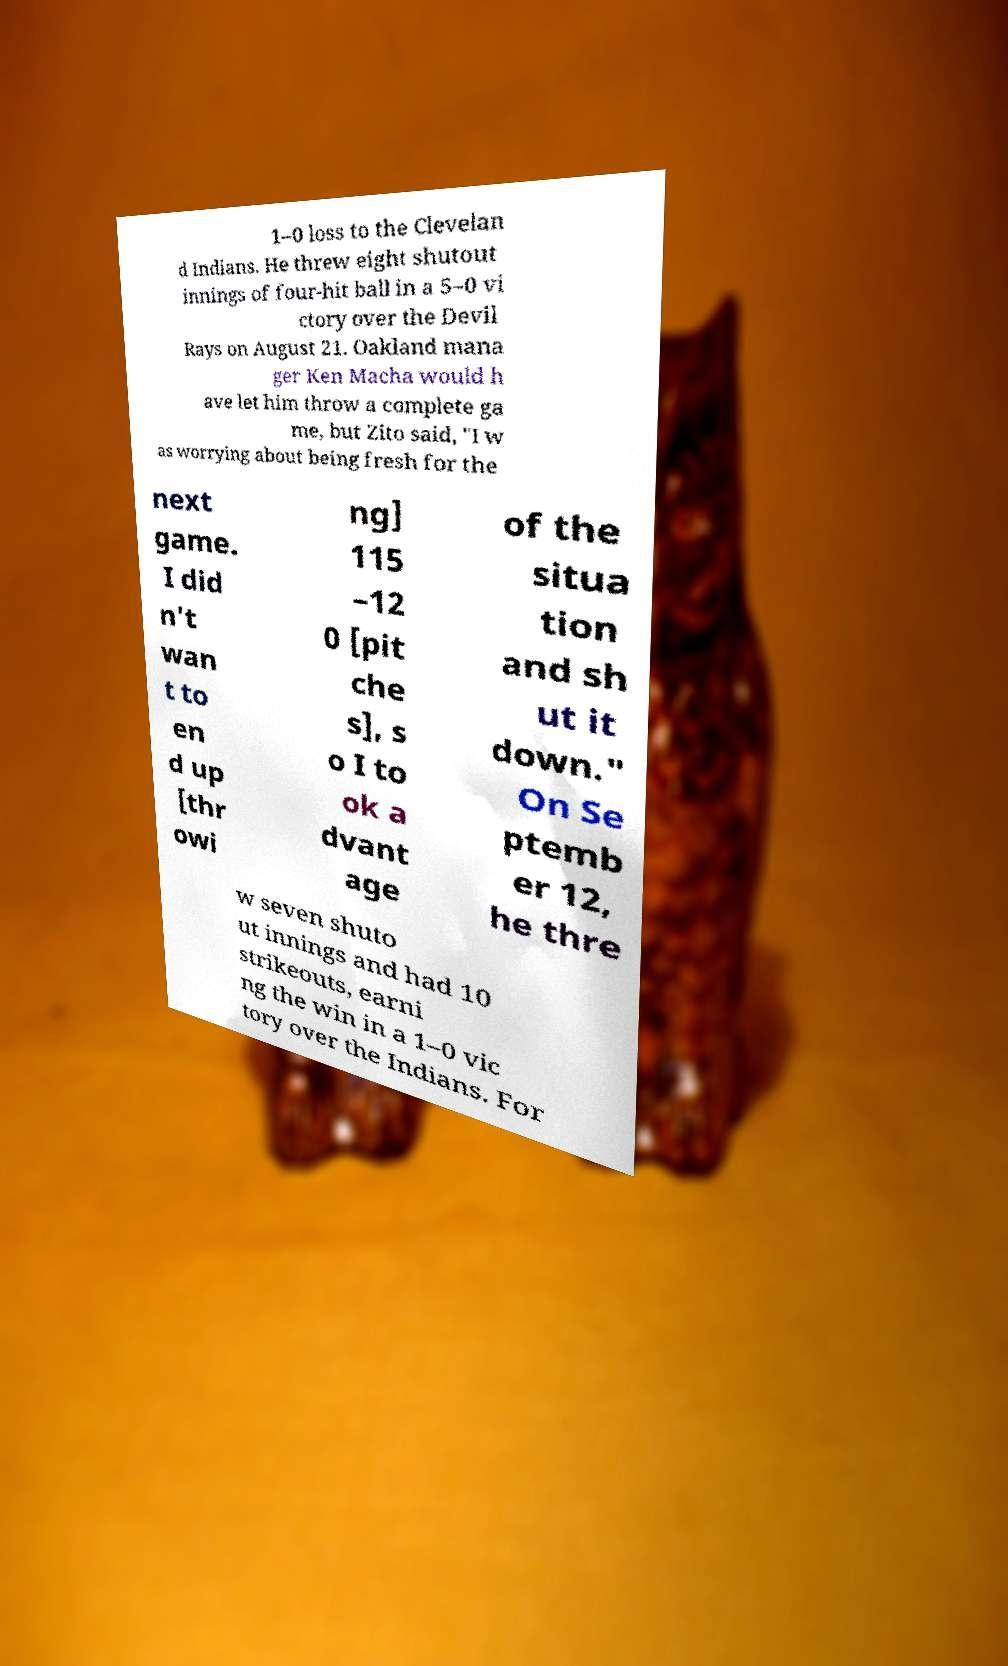Could you extract and type out the text from this image? 1–0 loss to the Clevelan d Indians. He threw eight shutout innings of four-hit ball in a 5–0 vi ctory over the Devil Rays on August 21. Oakland mana ger Ken Macha would h ave let him throw a complete ga me, but Zito said, "I w as worrying about being fresh for the next game. I did n't wan t to en d up [thr owi ng] 115 –12 0 [pit che s], s o I to ok a dvant age of the situa tion and sh ut it down." On Se ptemb er 12, he thre w seven shuto ut innings and had 10 strikeouts, earni ng the win in a 1–0 vic tory over the Indians. For 